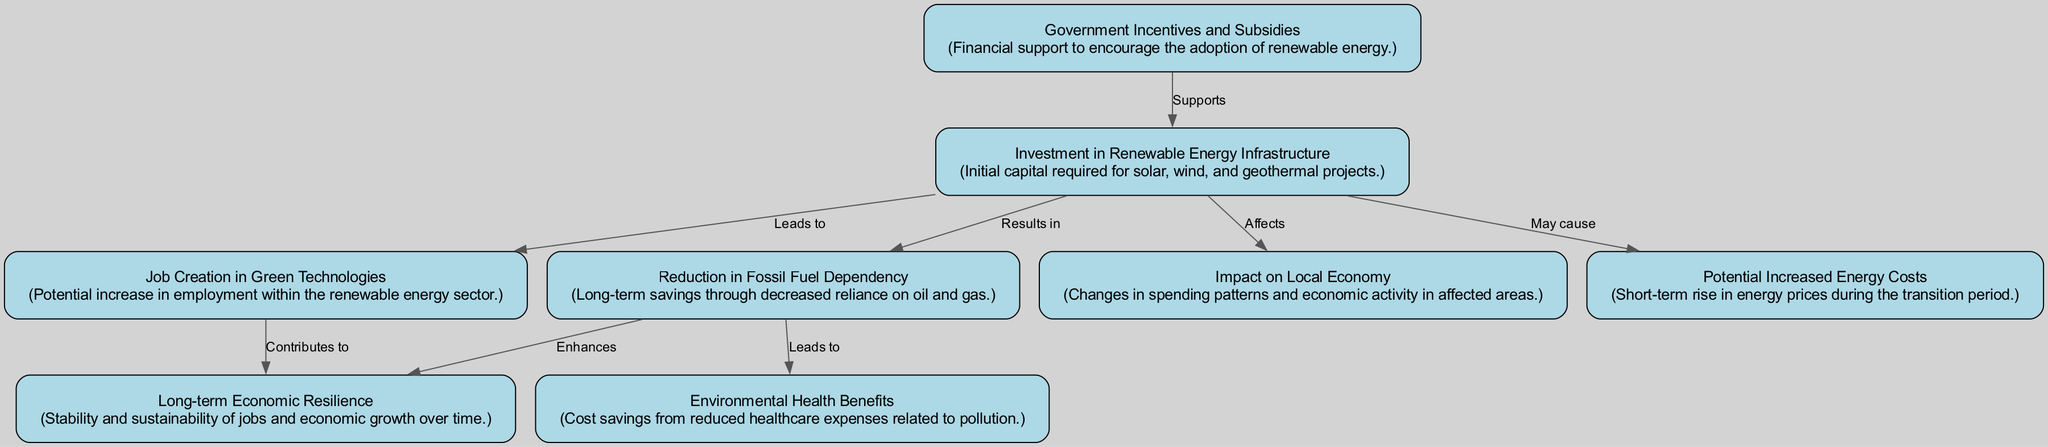What is the first step of the economic impact analysis? The diagram indicates that the first step is "Investment in Renewable Energy Infrastructure", which is essential for initiating the process of analyzing the economic impact.
Answer: Investment in Renewable Energy Infrastructure How many nodes are present in the diagram? By counting each unique element in the diagram, we find that there are a total of eight nodes representing different aspects of the economic impact analysis.
Answer: Eight What is the relationship between "Investment in Renewable Energy Infrastructure" and "Job Creation in Green Technologies"? The diagram shows an arrow from "Investment in Renewable Energy Infrastructure" to "Job Creation in Green Technologies" labeled as "Leads to", indicating that the investment is expected to result in job creation.
Answer: Leads to What long-term benefit is associated with "Reduction in Fossil Fuel Dependency"? The arrow from "Reduction in Fossil Fuel Dependency" to "Long-term Economic Resilience" shows that the reduction is expected to enhance economic stability and sustainability over time.
Answer: Enhances What potential negative effect is mentioned in relation to "Investment in Renewable Energy Infrastructure"? The diagram highlights that "Investment in Renewable Energy Infrastructure" may cause a "Potential Increased Energy Costs", indicating a short-term rise in prices during the transition period.
Answer: May cause Which element directly supports "Investment in Renewable Energy Infrastructure"? According to the diagram, "Government Incentives and Subsidies" directly supports "Investment in Renewable Energy Infrastructure", acting as financial encouragement for the adoption of renewable practices.
Answer: Government Incentives and Subsidies What is one healthcare-related benefit mentioned in the diagram? The diagram illustrates that "Environmental Health Benefits" result in cost savings related to reduced healthcare expenses due to pollution, highlighting a positive economic impact on public health.
Answer: Cost savings from reduced healthcare expenses What do efforts in "Job Creation in Green Technologies" contribute to as a long-term effect? The flow from "Job Creation in Green Technologies" leads to "Long-term Economic Resilience", suggesting that increased jobs in this sector provide stability to the economy over time.
Answer: Contributes to What effect does "Reduction in Fossil Fuel Dependency" have on environmental health? The diagram shows a connection between "Reduction in Fossil Fuel Dependency" leading to "Environmental Health Benefits", indicating that reducing dependency can improve health outcomes by lowering pollution levels.
Answer: Leads to 